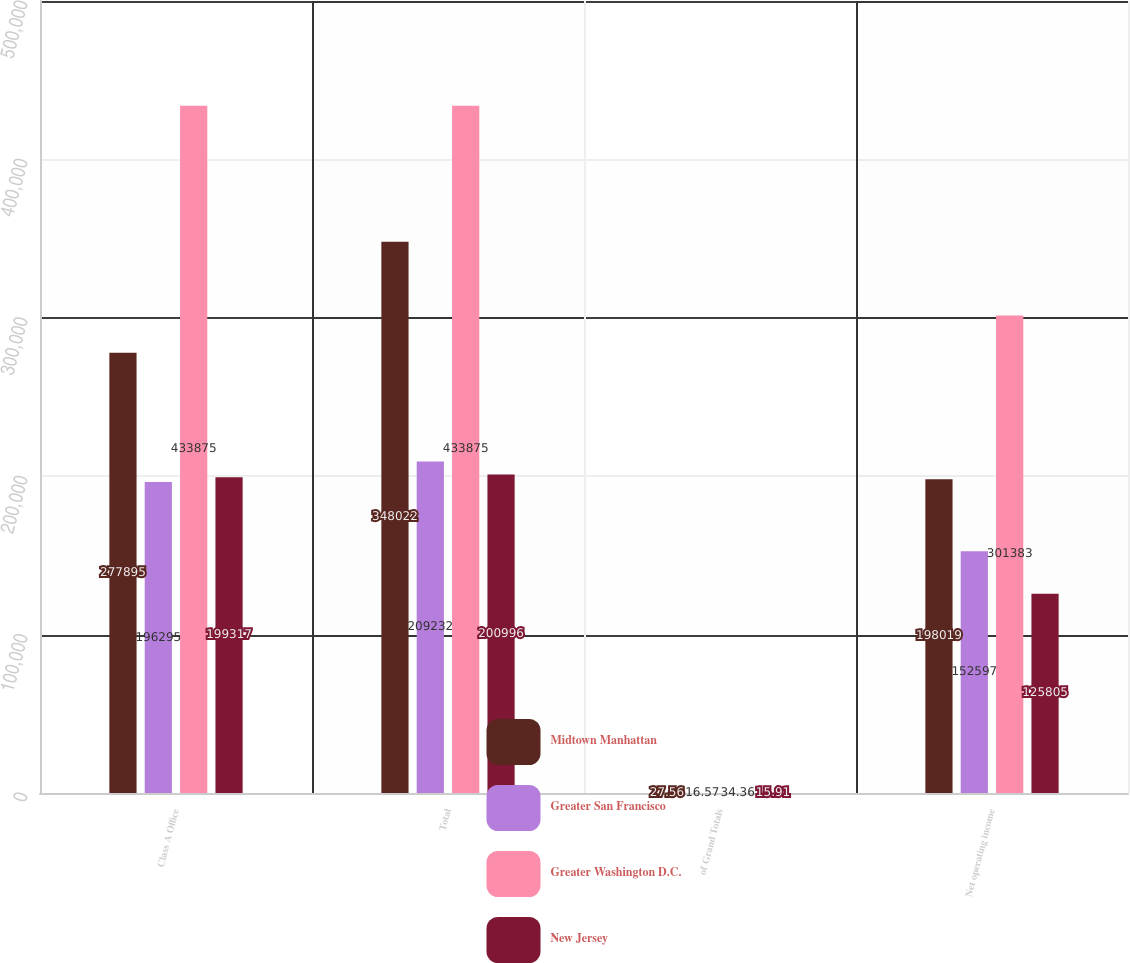Convert chart. <chart><loc_0><loc_0><loc_500><loc_500><stacked_bar_chart><ecel><fcel>Class A Office<fcel>Total<fcel>of Grand Totals<fcel>Net operating income<nl><fcel>Midtown Manhattan<fcel>277895<fcel>348022<fcel>27.56<fcel>198019<nl><fcel>Greater San Francisco<fcel>196295<fcel>209232<fcel>16.57<fcel>152597<nl><fcel>Greater Washington D.C.<fcel>433875<fcel>433875<fcel>34.36<fcel>301383<nl><fcel>New Jersey<fcel>199317<fcel>200996<fcel>15.91<fcel>125805<nl></chart> 